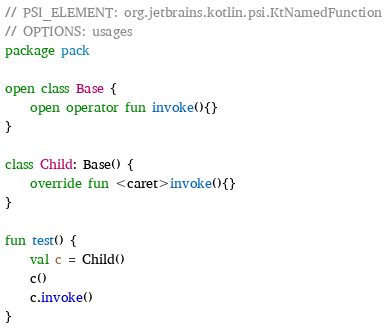<code> <loc_0><loc_0><loc_500><loc_500><_Kotlin_>// PSI_ELEMENT: org.jetbrains.kotlin.psi.KtNamedFunction
// OPTIONS: usages
package pack

open class Base {
    open operator fun invoke(){}
}

class Child: Base() {
    override fun <caret>invoke(){}
}

fun test() {
    val c = Child()
    c()
    c.invoke()
}
</code> 